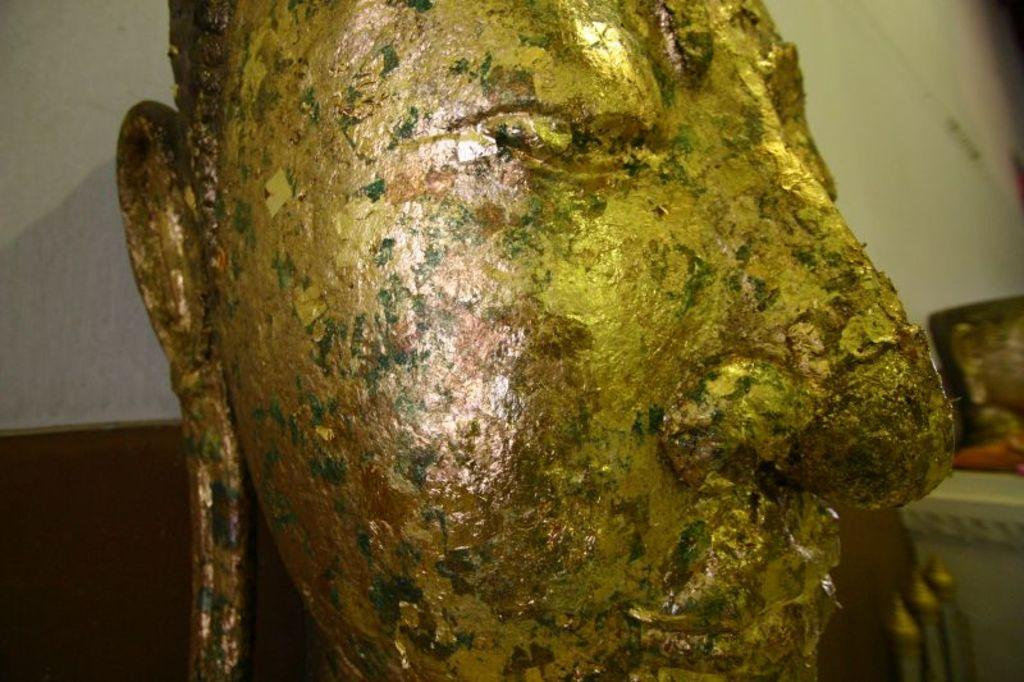What is the main subject of the image? There is a statue in the image. Can you describe the statue? The statue is of a human face. Where is the statue located in relation to other objects in the image? The statue is in front of a wall. Can you tell me how many ducks are swimming in the water near the statue? There are no ducks or water present in the image; it features a statue of a human face in front of a wall. 